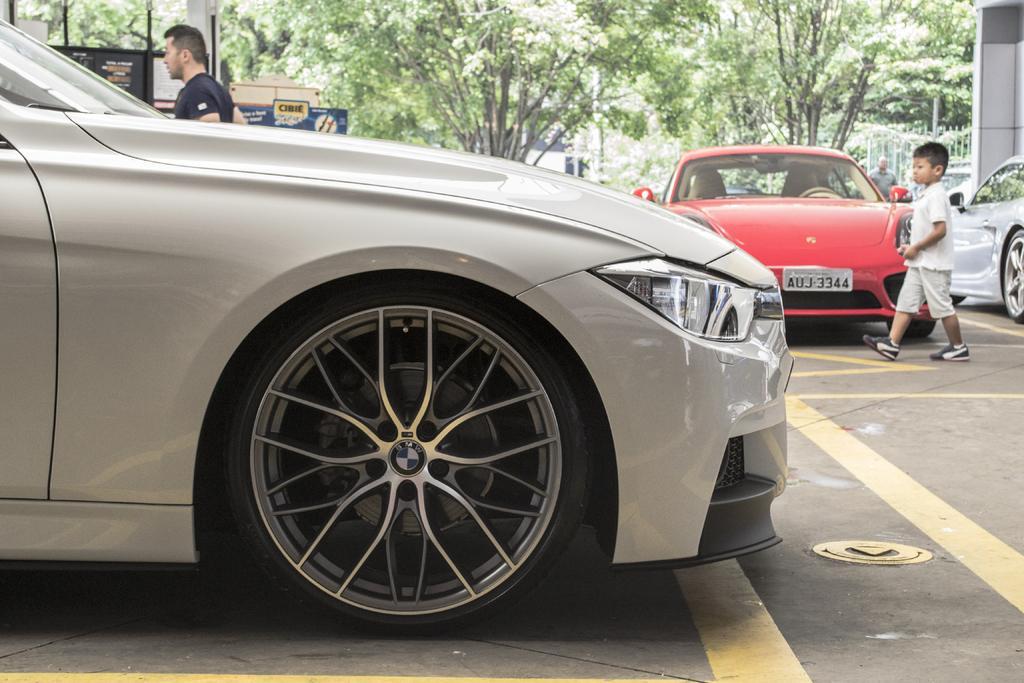In one or two sentences, can you explain what this image depicts? In the center of the image we can see cars, a man, a boy, trees, boards are there. At the bottom of the image road is present. On the right side of the image wall is there. 